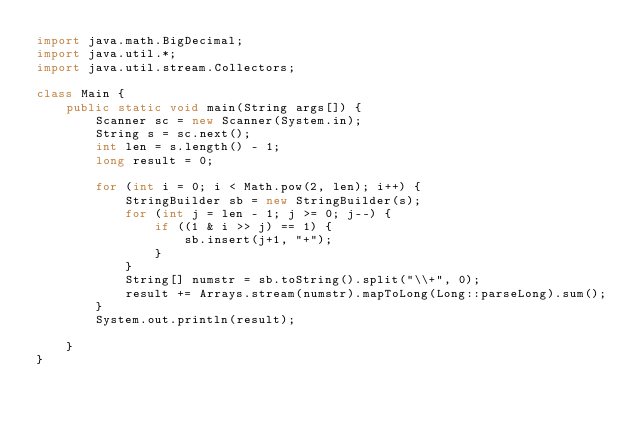Convert code to text. <code><loc_0><loc_0><loc_500><loc_500><_Java_>import java.math.BigDecimal;
import java.util.*;
import java.util.stream.Collectors;

class Main {
    public static void main(String args[]) {
        Scanner sc = new Scanner(System.in);
        String s = sc.next();
        int len = s.length() - 1;
        long result = 0;

        for (int i = 0; i < Math.pow(2, len); i++) {
            StringBuilder sb = new StringBuilder(s);
            for (int j = len - 1; j >= 0; j--) {
                if ((1 & i >> j) == 1) {
                    sb.insert(j+1, "+");
                }
            }
            String[] numstr = sb.toString().split("\\+", 0);
            result += Arrays.stream(numstr).mapToLong(Long::parseLong).sum();
        }
        System.out.println(result);

    }
}</code> 